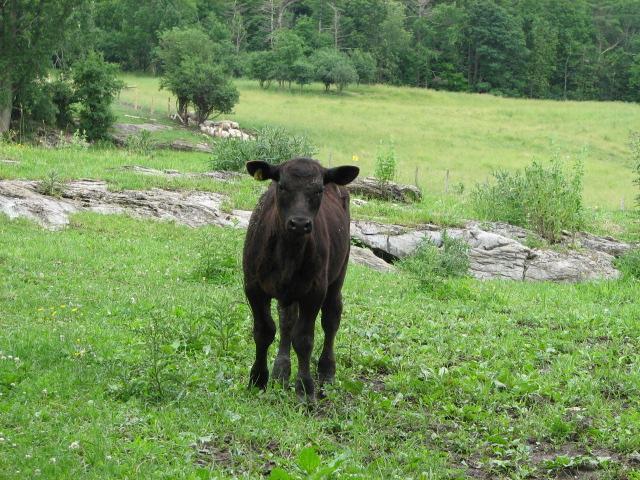How many cows?
Give a very brief answer. 1. 